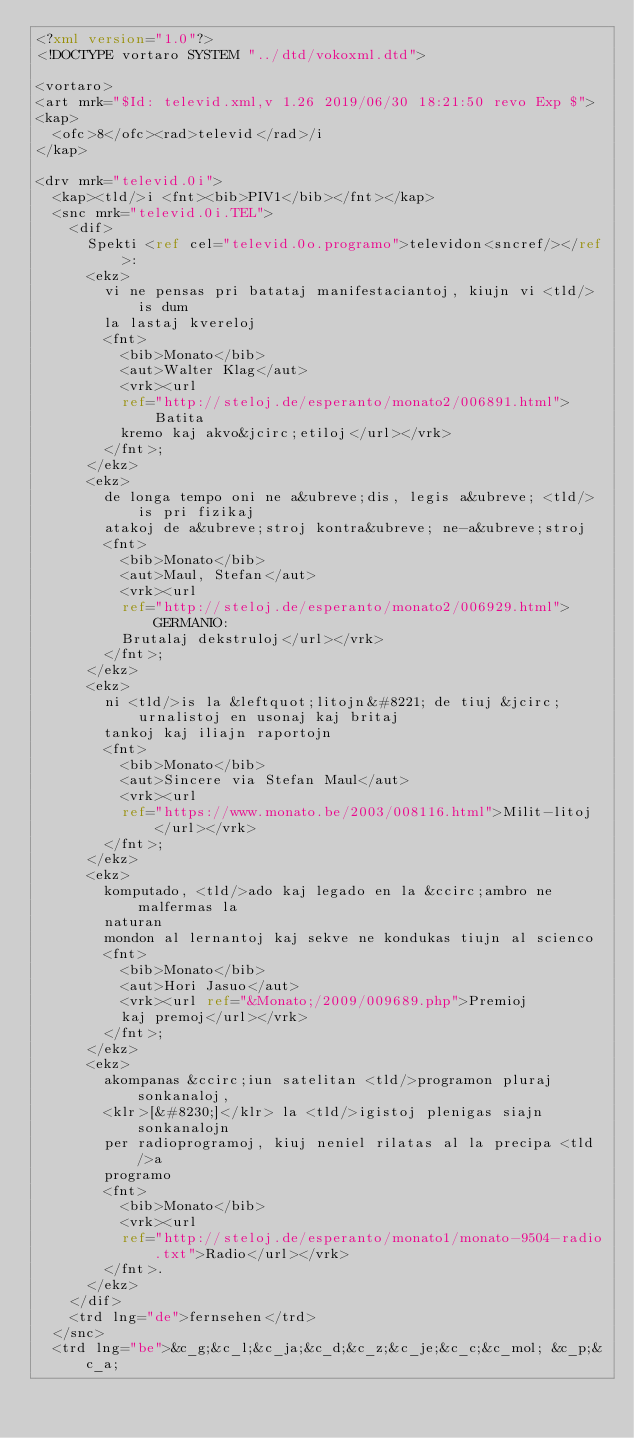<code> <loc_0><loc_0><loc_500><loc_500><_XML_><?xml version="1.0"?>
<!DOCTYPE vortaro SYSTEM "../dtd/vokoxml.dtd">

<vortaro>
<art mrk="$Id: televid.xml,v 1.26 2019/06/30 18:21:50 revo Exp $">
<kap>
  <ofc>8</ofc><rad>televid</rad>/i
</kap>

<drv mrk="televid.0i">
  <kap><tld/>i <fnt><bib>PIV1</bib></fnt></kap>
  <snc mrk="televid.0i.TEL">
    <dif>
      Spekti <ref cel="televid.0o.programo">televidon<sncref/></ref>:
      <ekz>
        vi ne pensas pri batataj manifestaciantoj, kiujn vi <tld/>is dum
        la lastaj kvereloj
        <fnt>
          <bib>Monato</bib>
          <aut>Walter Klag</aut>
          <vrk><url
          ref="http://steloj.de/esperanto/monato2/006891.html">Batita
          kremo kaj akvo&jcirc;etiloj</url></vrk>
        </fnt>;
      </ekz>
      <ekz>
        de longa tempo oni ne a&ubreve;dis, legis a&ubreve; <tld/>is pri fizikaj
        atakoj de a&ubreve;stroj kontra&ubreve; ne-a&ubreve;stroj
        <fnt>
          <bib>Monato</bib>
          <aut>Maul, Stefan</aut>
          <vrk><url
          ref="http://steloj.de/esperanto/monato2/006929.html">GERMANIO:
          Brutalaj dekstruloj</url></vrk>
        </fnt>;
      </ekz>
      <ekz>
        ni <tld/>is la &leftquot;litojn&#8221; de tiuj &jcirc;urnalistoj en usonaj kaj britaj
        tankoj kaj iliajn raportojn
        <fnt>
          <bib>Monato</bib>
          <aut>Sincere via Stefan Maul</aut>
          <vrk><url
          ref="https://www.monato.be/2003/008116.html">Milit-litoj</url></vrk>
        </fnt>;
      </ekz>
      <ekz>
        komputado, <tld/>ado kaj legado en la &ccirc;ambro ne malfermas la
        naturan
        mondon al lernantoj kaj sekve ne kondukas tiujn al scienco
        <fnt>
          <bib>Monato</bib>
          <aut>Hori Jasuo</aut>
          <vrk><url ref="&Monato;/2009/009689.php">Premioj
          kaj premoj</url></vrk>
        </fnt>;
      </ekz>
      <ekz>
        akompanas &ccirc;iun satelitan <tld/>programon pluraj sonkanaloj,
        <klr>[&#8230;]</klr> la <tld/>igistoj plenigas siajn sonkanalojn 
        per radioprogramoj, kiuj neniel rilatas al la precipa <tld/>a
        programo
        <fnt>
          <bib>Monato</bib>
          <vrk><url
          ref="http://steloj.de/esperanto/monato1/monato-9504-radio.txt">Radio</url></vrk>
        </fnt>.
      </ekz>
    </dif>
    <trd lng="de">fernsehen</trd>
  </snc>
  <trd lng="be">&c_g;&c_l;&c_ja;&c_d;&c_z;&c_je;&c_c;&c_mol; &c_p;&c_a; </code> 